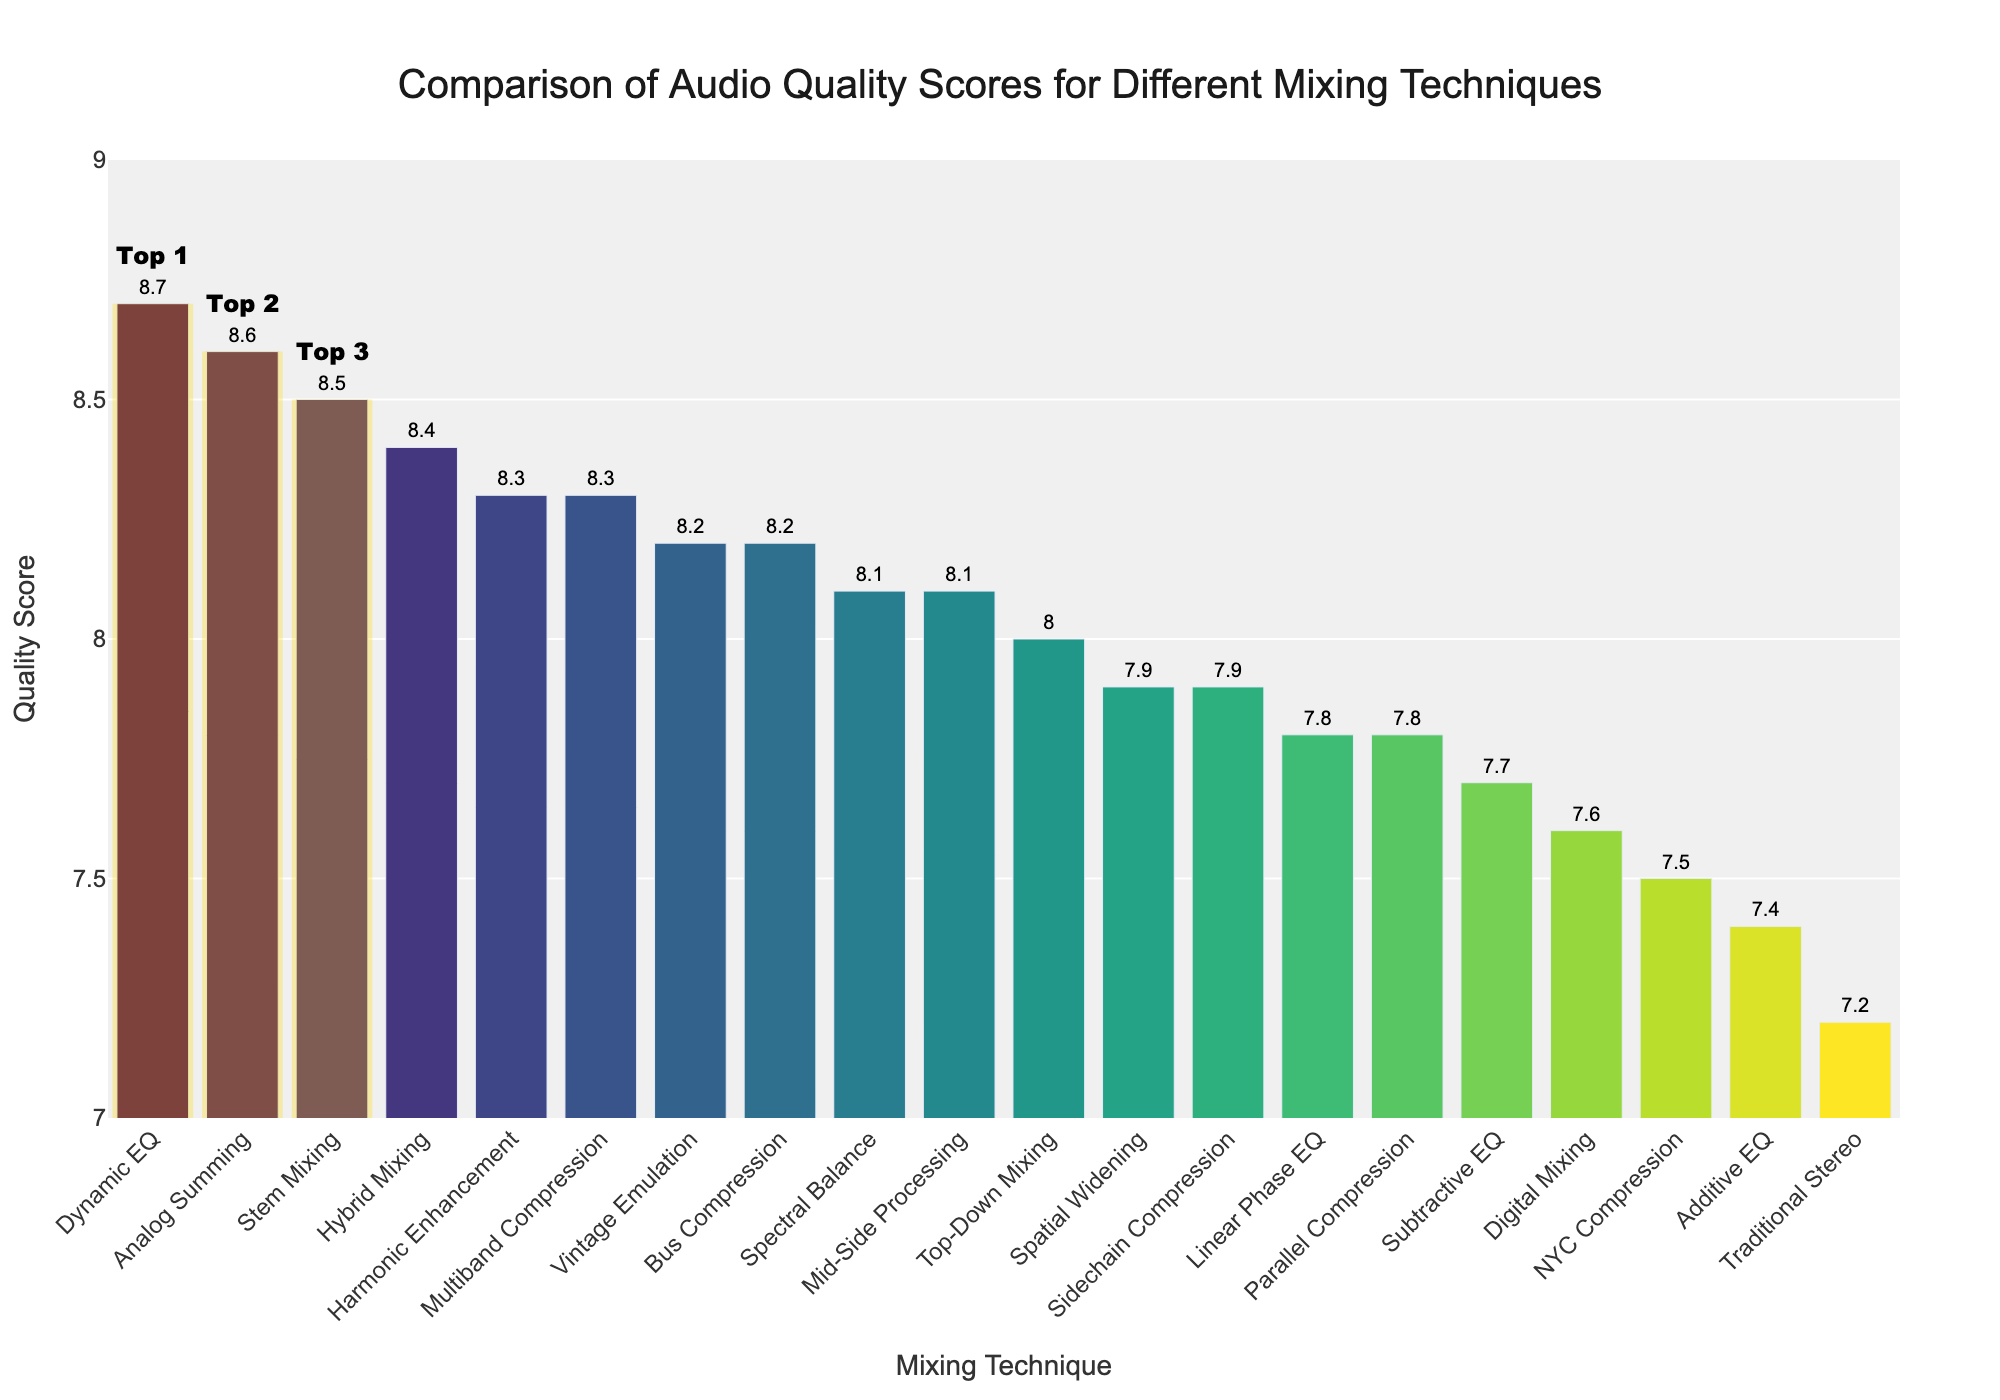What are the top 3 mixing techniques based on audio quality scores? The bars for the top 3 mixing techniques are emphasized with a gold rectangle; the techniques are Dynamic EQ, Analog Summing, and Stem Mixing, with the highest Quality Scores.
Answer: Dynamic EQ, Analog Summing, Stem Mixing Which mixing technique has the lowest quality score, and what's its value? The shortest bar corresponds to the Traditional Stereo technique with a Quality Score of 7.2, which is the lowest in the chart.
Answer: Traditional Stereo, 7.2 What is the difference in quality score between Stem Mixing and Digital Mixing? The Quality Score for Stem Mixing is 8.5, and for Digital Mixing, it is 7.6. The difference is calculated as 8.5 - 7.6.
Answer: 0.9 Which mixing techniques have a quality score greater than 8.2 but less than 8.6? The bars that fall in the range greater than 8.2 but less than 8.6 belong to Analog Summing, Bus Compression, and Vintage Emulation.
Answer: Analog Summing, Bus Compression, Vintage Emulation How many techniques have a quality score less than 8.0? Techniques with Quality Scores below 8.0 include Traditional Stereo, NYC Compression, Additive EQ, Digital Mixing, Subtractive EQ, Linear Phase EQ, and Sidechain Compression. There are seven such techniques.
Answer: 7 What is the average quality score of the top 5 mixing techniques? The top 5 mixing techniques are Dynamic EQ (8.7), Analog Summing (8.6), Stem Mixing (8.5), Hybrid Mixing (8.4), and Multiband Compression (8.3). Sum these scores: 8.7 + 8.6 + 8.5 + 8.4 + 8.3 = 42.5, then divide by 5.
Answer: 8.5 Which mixing technique ranks fifth in quality scores, and what is its value? Looking at the sorted bars, the fifth one is Multiband Compression with a Quality Score of 8.3.
Answer: Multiband Compression, 8.3 How many techniques have a quality score exactly equal to 7.8? From the bars, Parallel Compression and Linear Phase EQ both have Quality Scores of 7.8, indicating two techniques meet this criterion.
Answer: 2 Which technique has a higher quality score: Mid-Side Processing or Spatial Widening? Comparing Mid-Side Processing and Spatial Widening, Mid-Side Processing has a Quality Score of 8.1 while Spatial Widening has a score of 7.9. Thus, Mid-Side Processing is higher.
Answer: Mid-Side Processing What percentage of techniques have a quality score of 8.0 or higher? Count the techniques having Quality Scores 8.0 and above (13 techniques) out of the total techniques (20). Calculate the percentage as (13/20) * 100.
Answer: 65% 